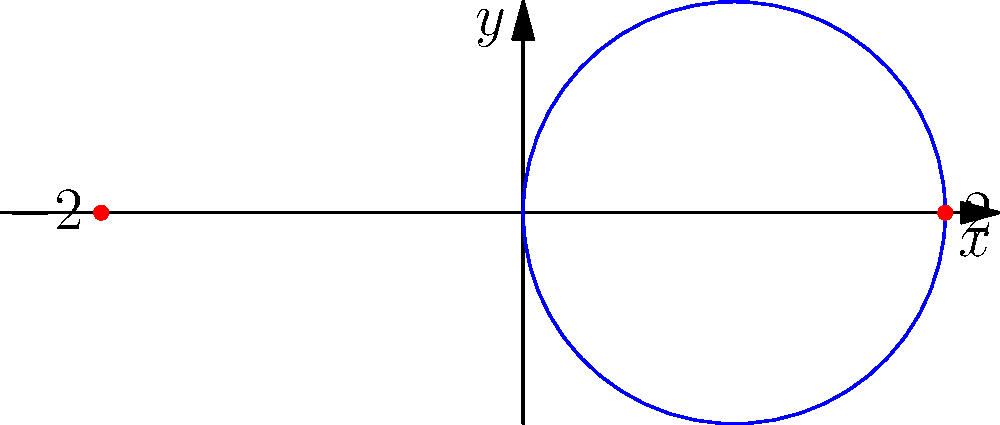As part of integrating STEM concepts into the curriculum, you're developing a lesson on coordinate systems. Convert the polar equation $r = 2\cos(\theta)$ to Cartesian coordinates and sketch the resulting graph. What type of conic section does this equation represent, and what are its key features? To convert the polar equation $r = 2\cos(\theta)$ to Cartesian coordinates and analyze the graph, follow these steps:

1) Use the conversion formulas:
   $x = r\cos(\theta)$ and $y = r\sin(\theta)$

2) Substitute $r = 2\cos(\theta)$ into these formulas:
   $x = 2\cos(\theta)\cos(\theta)$ and $y = 2\cos(\theta)\sin(\theta)$

3) For $x$, use the identity $\cos^2(\theta) = \frac{1 + \cos(2\theta)}{2}$:
   $x = 2 \cdot \frac{1 + \cos(2\theta)}{2} = 1 + \cos(2\theta)$

4) For $y$, use the identity $\sin(2\theta) = 2\sin(\theta)\cos(\theta)$:
   $y = \sin(2\theta)$

5) From steps 3 and 4, we can write:
   $x - 1 = \cos(2\theta)$ and $y = \sin(2\theta)$

6) Square and add these equations:
   $(x - 1)^2 + y^2 = \cos^2(2\theta) + \sin^2(2\theta) = 1$

7) This is the standard form of a circle equation $(x - h)^2 + (y - k)^2 = r^2$, where:
   - Center: $(h, k) = (1, 0)$
   - Radius: $r = 1$

8) Key features of the graph:
   - It's a circle
   - Center at (1, 0)
   - Radius of 1
   - Passes through points (0, 0) and (2, 0)

The graph is shown in the provided figure, with the circle in blue and its leftmost and rightmost points marked in red.
Answer: Circle with center (1, 0) and radius 1 